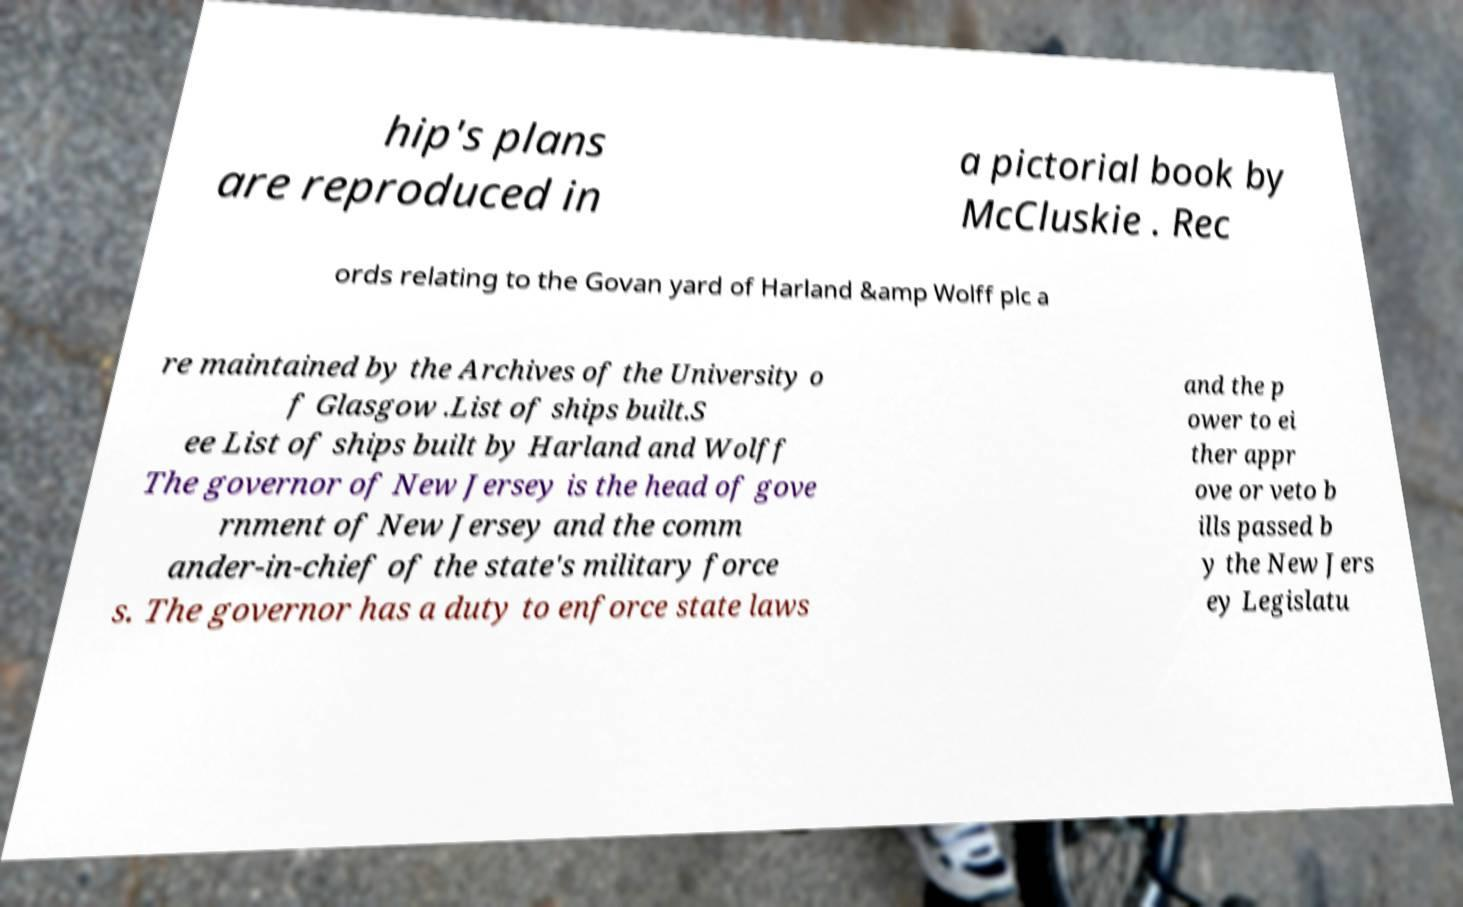Can you accurately transcribe the text from the provided image for me? hip's plans are reproduced in a pictorial book by McCluskie . Rec ords relating to the Govan yard of Harland &amp Wolff plc a re maintained by the Archives of the University o f Glasgow .List of ships built.S ee List of ships built by Harland and Wolff The governor of New Jersey is the head of gove rnment of New Jersey and the comm ander-in-chief of the state's military force s. The governor has a duty to enforce state laws and the p ower to ei ther appr ove or veto b ills passed b y the New Jers ey Legislatu 